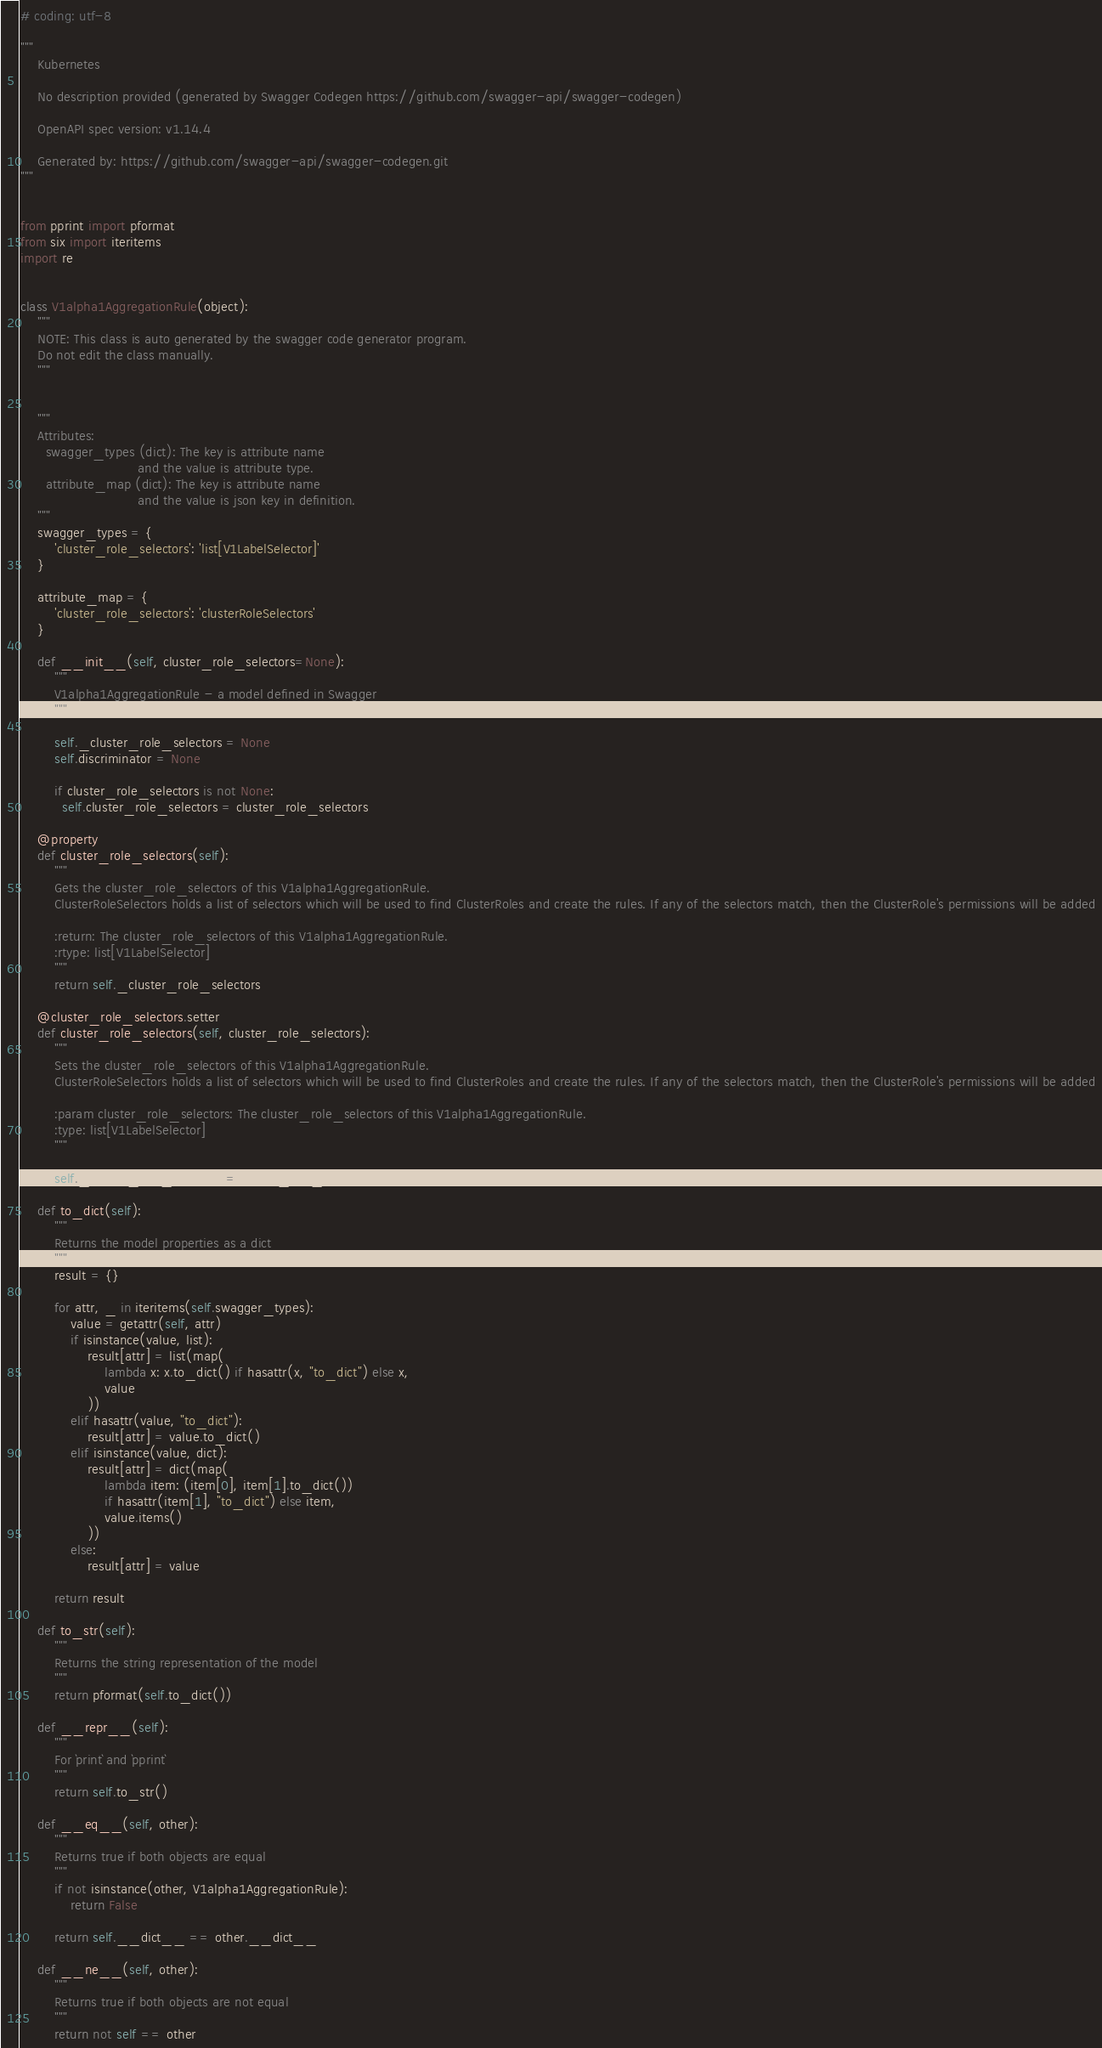<code> <loc_0><loc_0><loc_500><loc_500><_Python_># coding: utf-8

"""
    Kubernetes

    No description provided (generated by Swagger Codegen https://github.com/swagger-api/swagger-codegen)

    OpenAPI spec version: v1.14.4
    
    Generated by: https://github.com/swagger-api/swagger-codegen.git
"""


from pprint import pformat
from six import iteritems
import re


class V1alpha1AggregationRule(object):
    """
    NOTE: This class is auto generated by the swagger code generator program.
    Do not edit the class manually.
    """


    """
    Attributes:
      swagger_types (dict): The key is attribute name
                            and the value is attribute type.
      attribute_map (dict): The key is attribute name
                            and the value is json key in definition.
    """
    swagger_types = {
        'cluster_role_selectors': 'list[V1LabelSelector]'
    }

    attribute_map = {
        'cluster_role_selectors': 'clusterRoleSelectors'
    }

    def __init__(self, cluster_role_selectors=None):
        """
        V1alpha1AggregationRule - a model defined in Swagger
        """

        self._cluster_role_selectors = None
        self.discriminator = None

        if cluster_role_selectors is not None:
          self.cluster_role_selectors = cluster_role_selectors

    @property
    def cluster_role_selectors(self):
        """
        Gets the cluster_role_selectors of this V1alpha1AggregationRule.
        ClusterRoleSelectors holds a list of selectors which will be used to find ClusterRoles and create the rules. If any of the selectors match, then the ClusterRole's permissions will be added

        :return: The cluster_role_selectors of this V1alpha1AggregationRule.
        :rtype: list[V1LabelSelector]
        """
        return self._cluster_role_selectors

    @cluster_role_selectors.setter
    def cluster_role_selectors(self, cluster_role_selectors):
        """
        Sets the cluster_role_selectors of this V1alpha1AggregationRule.
        ClusterRoleSelectors holds a list of selectors which will be used to find ClusterRoles and create the rules. If any of the selectors match, then the ClusterRole's permissions will be added

        :param cluster_role_selectors: The cluster_role_selectors of this V1alpha1AggregationRule.
        :type: list[V1LabelSelector]
        """

        self._cluster_role_selectors = cluster_role_selectors

    def to_dict(self):
        """
        Returns the model properties as a dict
        """
        result = {}

        for attr, _ in iteritems(self.swagger_types):
            value = getattr(self, attr)
            if isinstance(value, list):
                result[attr] = list(map(
                    lambda x: x.to_dict() if hasattr(x, "to_dict") else x,
                    value
                ))
            elif hasattr(value, "to_dict"):
                result[attr] = value.to_dict()
            elif isinstance(value, dict):
                result[attr] = dict(map(
                    lambda item: (item[0], item[1].to_dict())
                    if hasattr(item[1], "to_dict") else item,
                    value.items()
                ))
            else:
                result[attr] = value

        return result

    def to_str(self):
        """
        Returns the string representation of the model
        """
        return pformat(self.to_dict())

    def __repr__(self):
        """
        For `print` and `pprint`
        """
        return self.to_str()

    def __eq__(self, other):
        """
        Returns true if both objects are equal
        """
        if not isinstance(other, V1alpha1AggregationRule):
            return False

        return self.__dict__ == other.__dict__

    def __ne__(self, other):
        """
        Returns true if both objects are not equal
        """
        return not self == other
</code> 